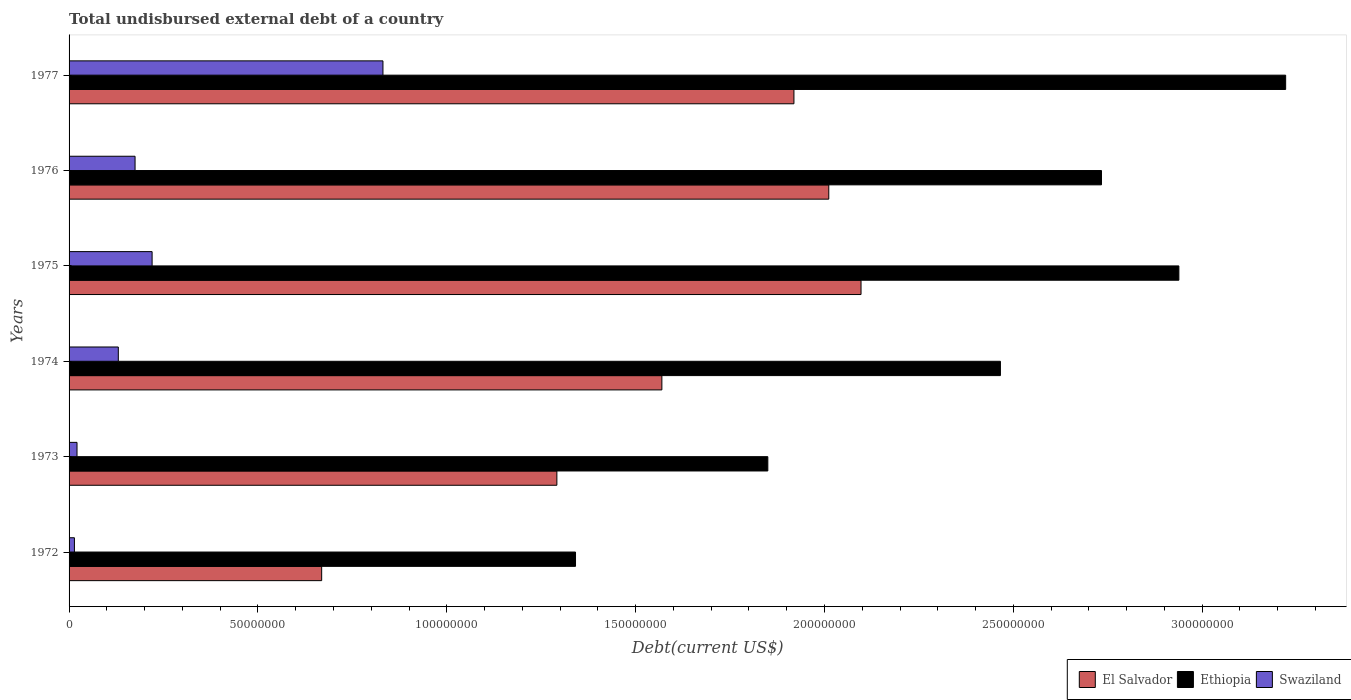Are the number of bars per tick equal to the number of legend labels?
Make the answer very short. Yes. How many bars are there on the 4th tick from the top?
Keep it short and to the point. 3. What is the total undisbursed external debt in Ethiopia in 1975?
Offer a terse response. 2.94e+08. Across all years, what is the maximum total undisbursed external debt in El Salvador?
Ensure brevity in your answer.  2.10e+08. Across all years, what is the minimum total undisbursed external debt in Swaziland?
Provide a succinct answer. 1.42e+06. In which year was the total undisbursed external debt in El Salvador maximum?
Your response must be concise. 1975. What is the total total undisbursed external debt in Ethiopia in the graph?
Make the answer very short. 1.45e+09. What is the difference between the total undisbursed external debt in Swaziland in 1973 and that in 1976?
Your response must be concise. -1.54e+07. What is the difference between the total undisbursed external debt in Ethiopia in 1977 and the total undisbursed external debt in El Salvador in 1973?
Offer a very short reply. 1.93e+08. What is the average total undisbursed external debt in Ethiopia per year?
Offer a terse response. 2.42e+08. In the year 1975, what is the difference between the total undisbursed external debt in Ethiopia and total undisbursed external debt in Swaziland?
Make the answer very short. 2.72e+08. In how many years, is the total undisbursed external debt in Ethiopia greater than 130000000 US$?
Give a very brief answer. 6. What is the ratio of the total undisbursed external debt in Ethiopia in 1972 to that in 1973?
Your answer should be very brief. 0.72. What is the difference between the highest and the second highest total undisbursed external debt in Ethiopia?
Ensure brevity in your answer.  2.83e+07. What is the difference between the highest and the lowest total undisbursed external debt in El Salvador?
Give a very brief answer. 1.43e+08. Is the sum of the total undisbursed external debt in Ethiopia in 1974 and 1975 greater than the maximum total undisbursed external debt in Swaziland across all years?
Your response must be concise. Yes. What does the 2nd bar from the top in 1974 represents?
Your answer should be compact. Ethiopia. What does the 3rd bar from the bottom in 1973 represents?
Your answer should be compact. Swaziland. Are all the bars in the graph horizontal?
Ensure brevity in your answer.  Yes. How many years are there in the graph?
Offer a terse response. 6. Where does the legend appear in the graph?
Make the answer very short. Bottom right. How many legend labels are there?
Offer a terse response. 3. What is the title of the graph?
Make the answer very short. Total undisbursed external debt of a country. Does "Guam" appear as one of the legend labels in the graph?
Ensure brevity in your answer.  No. What is the label or title of the X-axis?
Your answer should be compact. Debt(current US$). What is the Debt(current US$) of El Salvador in 1972?
Your answer should be very brief. 6.69e+07. What is the Debt(current US$) of Ethiopia in 1972?
Make the answer very short. 1.34e+08. What is the Debt(current US$) in Swaziland in 1972?
Your answer should be very brief. 1.42e+06. What is the Debt(current US$) in El Salvador in 1973?
Keep it short and to the point. 1.29e+08. What is the Debt(current US$) in Ethiopia in 1973?
Your answer should be compact. 1.85e+08. What is the Debt(current US$) in Swaziland in 1973?
Make the answer very short. 2.10e+06. What is the Debt(current US$) of El Salvador in 1974?
Give a very brief answer. 1.57e+08. What is the Debt(current US$) in Ethiopia in 1974?
Provide a succinct answer. 2.47e+08. What is the Debt(current US$) of Swaziland in 1974?
Your answer should be very brief. 1.30e+07. What is the Debt(current US$) in El Salvador in 1975?
Your answer should be very brief. 2.10e+08. What is the Debt(current US$) in Ethiopia in 1975?
Provide a succinct answer. 2.94e+08. What is the Debt(current US$) in Swaziland in 1975?
Your response must be concise. 2.20e+07. What is the Debt(current US$) of El Salvador in 1976?
Your answer should be very brief. 2.01e+08. What is the Debt(current US$) in Ethiopia in 1976?
Your answer should be very brief. 2.73e+08. What is the Debt(current US$) in Swaziland in 1976?
Your answer should be compact. 1.75e+07. What is the Debt(current US$) of El Salvador in 1977?
Provide a succinct answer. 1.92e+08. What is the Debt(current US$) of Ethiopia in 1977?
Your response must be concise. 3.22e+08. What is the Debt(current US$) of Swaziland in 1977?
Provide a succinct answer. 8.31e+07. Across all years, what is the maximum Debt(current US$) of El Salvador?
Your response must be concise. 2.10e+08. Across all years, what is the maximum Debt(current US$) in Ethiopia?
Provide a short and direct response. 3.22e+08. Across all years, what is the maximum Debt(current US$) in Swaziland?
Offer a terse response. 8.31e+07. Across all years, what is the minimum Debt(current US$) in El Salvador?
Your response must be concise. 6.69e+07. Across all years, what is the minimum Debt(current US$) of Ethiopia?
Your answer should be very brief. 1.34e+08. Across all years, what is the minimum Debt(current US$) of Swaziland?
Offer a very short reply. 1.42e+06. What is the total Debt(current US$) in El Salvador in the graph?
Provide a succinct answer. 9.56e+08. What is the total Debt(current US$) in Ethiopia in the graph?
Provide a succinct answer. 1.45e+09. What is the total Debt(current US$) of Swaziland in the graph?
Your answer should be compact. 1.39e+08. What is the difference between the Debt(current US$) of El Salvador in 1972 and that in 1973?
Offer a very short reply. -6.23e+07. What is the difference between the Debt(current US$) in Ethiopia in 1972 and that in 1973?
Your answer should be compact. -5.09e+07. What is the difference between the Debt(current US$) in Swaziland in 1972 and that in 1973?
Your answer should be very brief. -6.87e+05. What is the difference between the Debt(current US$) in El Salvador in 1972 and that in 1974?
Provide a succinct answer. -9.01e+07. What is the difference between the Debt(current US$) of Ethiopia in 1972 and that in 1974?
Offer a very short reply. -1.12e+08. What is the difference between the Debt(current US$) in Swaziland in 1972 and that in 1974?
Ensure brevity in your answer.  -1.16e+07. What is the difference between the Debt(current US$) in El Salvador in 1972 and that in 1975?
Your response must be concise. -1.43e+08. What is the difference between the Debt(current US$) in Ethiopia in 1972 and that in 1975?
Offer a very short reply. -1.60e+08. What is the difference between the Debt(current US$) of Swaziland in 1972 and that in 1975?
Your answer should be very brief. -2.06e+07. What is the difference between the Debt(current US$) of El Salvador in 1972 and that in 1976?
Your answer should be compact. -1.34e+08. What is the difference between the Debt(current US$) in Ethiopia in 1972 and that in 1976?
Keep it short and to the point. -1.39e+08. What is the difference between the Debt(current US$) in Swaziland in 1972 and that in 1976?
Your answer should be very brief. -1.61e+07. What is the difference between the Debt(current US$) of El Salvador in 1972 and that in 1977?
Your answer should be very brief. -1.25e+08. What is the difference between the Debt(current US$) of Ethiopia in 1972 and that in 1977?
Offer a very short reply. -1.88e+08. What is the difference between the Debt(current US$) in Swaziland in 1972 and that in 1977?
Make the answer very short. -8.17e+07. What is the difference between the Debt(current US$) of El Salvador in 1973 and that in 1974?
Make the answer very short. -2.78e+07. What is the difference between the Debt(current US$) of Ethiopia in 1973 and that in 1974?
Make the answer very short. -6.16e+07. What is the difference between the Debt(current US$) in Swaziland in 1973 and that in 1974?
Provide a succinct answer. -1.09e+07. What is the difference between the Debt(current US$) in El Salvador in 1973 and that in 1975?
Ensure brevity in your answer.  -8.05e+07. What is the difference between the Debt(current US$) of Ethiopia in 1973 and that in 1975?
Provide a short and direct response. -1.09e+08. What is the difference between the Debt(current US$) in Swaziland in 1973 and that in 1975?
Provide a succinct answer. -1.99e+07. What is the difference between the Debt(current US$) of El Salvador in 1973 and that in 1976?
Provide a short and direct response. -7.20e+07. What is the difference between the Debt(current US$) of Ethiopia in 1973 and that in 1976?
Make the answer very short. -8.83e+07. What is the difference between the Debt(current US$) in Swaziland in 1973 and that in 1976?
Keep it short and to the point. -1.54e+07. What is the difference between the Debt(current US$) of El Salvador in 1973 and that in 1977?
Offer a very short reply. -6.28e+07. What is the difference between the Debt(current US$) in Ethiopia in 1973 and that in 1977?
Your answer should be compact. -1.37e+08. What is the difference between the Debt(current US$) of Swaziland in 1973 and that in 1977?
Give a very brief answer. -8.10e+07. What is the difference between the Debt(current US$) of El Salvador in 1974 and that in 1975?
Ensure brevity in your answer.  -5.27e+07. What is the difference between the Debt(current US$) in Ethiopia in 1974 and that in 1975?
Provide a succinct answer. -4.72e+07. What is the difference between the Debt(current US$) in Swaziland in 1974 and that in 1975?
Offer a very short reply. -8.95e+06. What is the difference between the Debt(current US$) in El Salvador in 1974 and that in 1976?
Your answer should be very brief. -4.42e+07. What is the difference between the Debt(current US$) in Ethiopia in 1974 and that in 1976?
Keep it short and to the point. -2.68e+07. What is the difference between the Debt(current US$) of Swaziland in 1974 and that in 1976?
Your answer should be compact. -4.43e+06. What is the difference between the Debt(current US$) in El Salvador in 1974 and that in 1977?
Provide a succinct answer. -3.50e+07. What is the difference between the Debt(current US$) in Ethiopia in 1974 and that in 1977?
Keep it short and to the point. -7.55e+07. What is the difference between the Debt(current US$) in Swaziland in 1974 and that in 1977?
Ensure brevity in your answer.  -7.01e+07. What is the difference between the Debt(current US$) of El Salvador in 1975 and that in 1976?
Offer a very short reply. 8.54e+06. What is the difference between the Debt(current US$) in Ethiopia in 1975 and that in 1976?
Offer a very short reply. 2.05e+07. What is the difference between the Debt(current US$) in Swaziland in 1975 and that in 1976?
Provide a short and direct response. 4.52e+06. What is the difference between the Debt(current US$) in El Salvador in 1975 and that in 1977?
Make the answer very short. 1.78e+07. What is the difference between the Debt(current US$) in Ethiopia in 1975 and that in 1977?
Your response must be concise. -2.83e+07. What is the difference between the Debt(current US$) in Swaziland in 1975 and that in 1977?
Your response must be concise. -6.11e+07. What is the difference between the Debt(current US$) of El Salvador in 1976 and that in 1977?
Offer a very short reply. 9.23e+06. What is the difference between the Debt(current US$) in Ethiopia in 1976 and that in 1977?
Offer a very short reply. -4.88e+07. What is the difference between the Debt(current US$) of Swaziland in 1976 and that in 1977?
Keep it short and to the point. -6.56e+07. What is the difference between the Debt(current US$) of El Salvador in 1972 and the Debt(current US$) of Ethiopia in 1973?
Give a very brief answer. -1.18e+08. What is the difference between the Debt(current US$) in El Salvador in 1972 and the Debt(current US$) in Swaziland in 1973?
Ensure brevity in your answer.  6.48e+07. What is the difference between the Debt(current US$) in Ethiopia in 1972 and the Debt(current US$) in Swaziland in 1973?
Offer a very short reply. 1.32e+08. What is the difference between the Debt(current US$) of El Salvador in 1972 and the Debt(current US$) of Ethiopia in 1974?
Keep it short and to the point. -1.80e+08. What is the difference between the Debt(current US$) in El Salvador in 1972 and the Debt(current US$) in Swaziland in 1974?
Your answer should be very brief. 5.38e+07. What is the difference between the Debt(current US$) of Ethiopia in 1972 and the Debt(current US$) of Swaziland in 1974?
Ensure brevity in your answer.  1.21e+08. What is the difference between the Debt(current US$) in El Salvador in 1972 and the Debt(current US$) in Ethiopia in 1975?
Ensure brevity in your answer.  -2.27e+08. What is the difference between the Debt(current US$) of El Salvador in 1972 and the Debt(current US$) of Swaziland in 1975?
Offer a terse response. 4.49e+07. What is the difference between the Debt(current US$) in Ethiopia in 1972 and the Debt(current US$) in Swaziland in 1975?
Give a very brief answer. 1.12e+08. What is the difference between the Debt(current US$) in El Salvador in 1972 and the Debt(current US$) in Ethiopia in 1976?
Your answer should be very brief. -2.06e+08. What is the difference between the Debt(current US$) of El Salvador in 1972 and the Debt(current US$) of Swaziland in 1976?
Provide a succinct answer. 4.94e+07. What is the difference between the Debt(current US$) of Ethiopia in 1972 and the Debt(current US$) of Swaziland in 1976?
Ensure brevity in your answer.  1.17e+08. What is the difference between the Debt(current US$) in El Salvador in 1972 and the Debt(current US$) in Ethiopia in 1977?
Ensure brevity in your answer.  -2.55e+08. What is the difference between the Debt(current US$) of El Salvador in 1972 and the Debt(current US$) of Swaziland in 1977?
Provide a succinct answer. -1.62e+07. What is the difference between the Debt(current US$) of Ethiopia in 1972 and the Debt(current US$) of Swaziland in 1977?
Offer a terse response. 5.10e+07. What is the difference between the Debt(current US$) in El Salvador in 1973 and the Debt(current US$) in Ethiopia in 1974?
Your answer should be compact. -1.17e+08. What is the difference between the Debt(current US$) in El Salvador in 1973 and the Debt(current US$) in Swaziland in 1974?
Your response must be concise. 1.16e+08. What is the difference between the Debt(current US$) in Ethiopia in 1973 and the Debt(current US$) in Swaziland in 1974?
Your response must be concise. 1.72e+08. What is the difference between the Debt(current US$) of El Salvador in 1973 and the Debt(current US$) of Ethiopia in 1975?
Provide a succinct answer. -1.65e+08. What is the difference between the Debt(current US$) of El Salvador in 1973 and the Debt(current US$) of Swaziland in 1975?
Provide a short and direct response. 1.07e+08. What is the difference between the Debt(current US$) of Ethiopia in 1973 and the Debt(current US$) of Swaziland in 1975?
Provide a succinct answer. 1.63e+08. What is the difference between the Debt(current US$) in El Salvador in 1973 and the Debt(current US$) in Ethiopia in 1976?
Provide a short and direct response. -1.44e+08. What is the difference between the Debt(current US$) in El Salvador in 1973 and the Debt(current US$) in Swaziland in 1976?
Provide a short and direct response. 1.12e+08. What is the difference between the Debt(current US$) of Ethiopia in 1973 and the Debt(current US$) of Swaziland in 1976?
Give a very brief answer. 1.68e+08. What is the difference between the Debt(current US$) in El Salvador in 1973 and the Debt(current US$) in Ethiopia in 1977?
Offer a very short reply. -1.93e+08. What is the difference between the Debt(current US$) in El Salvador in 1973 and the Debt(current US$) in Swaziland in 1977?
Your response must be concise. 4.60e+07. What is the difference between the Debt(current US$) of Ethiopia in 1973 and the Debt(current US$) of Swaziland in 1977?
Keep it short and to the point. 1.02e+08. What is the difference between the Debt(current US$) of El Salvador in 1974 and the Debt(current US$) of Ethiopia in 1975?
Provide a succinct answer. -1.37e+08. What is the difference between the Debt(current US$) of El Salvador in 1974 and the Debt(current US$) of Swaziland in 1975?
Your answer should be very brief. 1.35e+08. What is the difference between the Debt(current US$) of Ethiopia in 1974 and the Debt(current US$) of Swaziland in 1975?
Ensure brevity in your answer.  2.25e+08. What is the difference between the Debt(current US$) of El Salvador in 1974 and the Debt(current US$) of Ethiopia in 1976?
Your answer should be compact. -1.16e+08. What is the difference between the Debt(current US$) of El Salvador in 1974 and the Debt(current US$) of Swaziland in 1976?
Give a very brief answer. 1.39e+08. What is the difference between the Debt(current US$) in Ethiopia in 1974 and the Debt(current US$) in Swaziland in 1976?
Provide a succinct answer. 2.29e+08. What is the difference between the Debt(current US$) of El Salvador in 1974 and the Debt(current US$) of Ethiopia in 1977?
Make the answer very short. -1.65e+08. What is the difference between the Debt(current US$) of El Salvador in 1974 and the Debt(current US$) of Swaziland in 1977?
Offer a very short reply. 7.38e+07. What is the difference between the Debt(current US$) in Ethiopia in 1974 and the Debt(current US$) in Swaziland in 1977?
Your answer should be compact. 1.63e+08. What is the difference between the Debt(current US$) of El Salvador in 1975 and the Debt(current US$) of Ethiopia in 1976?
Give a very brief answer. -6.37e+07. What is the difference between the Debt(current US$) of El Salvador in 1975 and the Debt(current US$) of Swaziland in 1976?
Offer a terse response. 1.92e+08. What is the difference between the Debt(current US$) of Ethiopia in 1975 and the Debt(current US$) of Swaziland in 1976?
Offer a very short reply. 2.76e+08. What is the difference between the Debt(current US$) of El Salvador in 1975 and the Debt(current US$) of Ethiopia in 1977?
Provide a short and direct response. -1.12e+08. What is the difference between the Debt(current US$) of El Salvador in 1975 and the Debt(current US$) of Swaziland in 1977?
Your answer should be compact. 1.27e+08. What is the difference between the Debt(current US$) of Ethiopia in 1975 and the Debt(current US$) of Swaziland in 1977?
Offer a terse response. 2.11e+08. What is the difference between the Debt(current US$) in El Salvador in 1976 and the Debt(current US$) in Ethiopia in 1977?
Keep it short and to the point. -1.21e+08. What is the difference between the Debt(current US$) of El Salvador in 1976 and the Debt(current US$) of Swaziland in 1977?
Your response must be concise. 1.18e+08. What is the difference between the Debt(current US$) of Ethiopia in 1976 and the Debt(current US$) of Swaziland in 1977?
Your answer should be very brief. 1.90e+08. What is the average Debt(current US$) in El Salvador per year?
Offer a very short reply. 1.59e+08. What is the average Debt(current US$) in Ethiopia per year?
Ensure brevity in your answer.  2.42e+08. What is the average Debt(current US$) in Swaziland per year?
Your answer should be compact. 2.32e+07. In the year 1972, what is the difference between the Debt(current US$) in El Salvador and Debt(current US$) in Ethiopia?
Give a very brief answer. -6.72e+07. In the year 1972, what is the difference between the Debt(current US$) of El Salvador and Debt(current US$) of Swaziland?
Provide a short and direct response. 6.55e+07. In the year 1972, what is the difference between the Debt(current US$) in Ethiopia and Debt(current US$) in Swaziland?
Your response must be concise. 1.33e+08. In the year 1973, what is the difference between the Debt(current US$) in El Salvador and Debt(current US$) in Ethiopia?
Offer a very short reply. -5.58e+07. In the year 1973, what is the difference between the Debt(current US$) in El Salvador and Debt(current US$) in Swaziland?
Give a very brief answer. 1.27e+08. In the year 1973, what is the difference between the Debt(current US$) in Ethiopia and Debt(current US$) in Swaziland?
Make the answer very short. 1.83e+08. In the year 1974, what is the difference between the Debt(current US$) in El Salvador and Debt(current US$) in Ethiopia?
Offer a very short reply. -8.96e+07. In the year 1974, what is the difference between the Debt(current US$) of El Salvador and Debt(current US$) of Swaziland?
Your answer should be compact. 1.44e+08. In the year 1974, what is the difference between the Debt(current US$) of Ethiopia and Debt(current US$) of Swaziland?
Provide a succinct answer. 2.34e+08. In the year 1975, what is the difference between the Debt(current US$) of El Salvador and Debt(current US$) of Ethiopia?
Make the answer very short. -8.42e+07. In the year 1975, what is the difference between the Debt(current US$) in El Salvador and Debt(current US$) in Swaziland?
Make the answer very short. 1.88e+08. In the year 1975, what is the difference between the Debt(current US$) in Ethiopia and Debt(current US$) in Swaziland?
Ensure brevity in your answer.  2.72e+08. In the year 1976, what is the difference between the Debt(current US$) of El Salvador and Debt(current US$) of Ethiopia?
Make the answer very short. -7.22e+07. In the year 1976, what is the difference between the Debt(current US$) in El Salvador and Debt(current US$) in Swaziland?
Offer a very short reply. 1.84e+08. In the year 1976, what is the difference between the Debt(current US$) in Ethiopia and Debt(current US$) in Swaziland?
Keep it short and to the point. 2.56e+08. In the year 1977, what is the difference between the Debt(current US$) of El Salvador and Debt(current US$) of Ethiopia?
Give a very brief answer. -1.30e+08. In the year 1977, what is the difference between the Debt(current US$) of El Salvador and Debt(current US$) of Swaziland?
Keep it short and to the point. 1.09e+08. In the year 1977, what is the difference between the Debt(current US$) in Ethiopia and Debt(current US$) in Swaziland?
Provide a short and direct response. 2.39e+08. What is the ratio of the Debt(current US$) in El Salvador in 1972 to that in 1973?
Ensure brevity in your answer.  0.52. What is the ratio of the Debt(current US$) in Ethiopia in 1972 to that in 1973?
Offer a very short reply. 0.72. What is the ratio of the Debt(current US$) of Swaziland in 1972 to that in 1973?
Make the answer very short. 0.67. What is the ratio of the Debt(current US$) in El Salvador in 1972 to that in 1974?
Ensure brevity in your answer.  0.43. What is the ratio of the Debt(current US$) of Ethiopia in 1972 to that in 1974?
Make the answer very short. 0.54. What is the ratio of the Debt(current US$) of Swaziland in 1972 to that in 1974?
Make the answer very short. 0.11. What is the ratio of the Debt(current US$) of El Salvador in 1972 to that in 1975?
Keep it short and to the point. 0.32. What is the ratio of the Debt(current US$) in Ethiopia in 1972 to that in 1975?
Your response must be concise. 0.46. What is the ratio of the Debt(current US$) in Swaziland in 1972 to that in 1975?
Offer a very short reply. 0.06. What is the ratio of the Debt(current US$) of El Salvador in 1972 to that in 1976?
Your answer should be very brief. 0.33. What is the ratio of the Debt(current US$) in Ethiopia in 1972 to that in 1976?
Your response must be concise. 0.49. What is the ratio of the Debt(current US$) in Swaziland in 1972 to that in 1976?
Ensure brevity in your answer.  0.08. What is the ratio of the Debt(current US$) in El Salvador in 1972 to that in 1977?
Keep it short and to the point. 0.35. What is the ratio of the Debt(current US$) in Ethiopia in 1972 to that in 1977?
Keep it short and to the point. 0.42. What is the ratio of the Debt(current US$) of Swaziland in 1972 to that in 1977?
Offer a very short reply. 0.02. What is the ratio of the Debt(current US$) in El Salvador in 1973 to that in 1974?
Your answer should be very brief. 0.82. What is the ratio of the Debt(current US$) of Ethiopia in 1973 to that in 1974?
Your answer should be very brief. 0.75. What is the ratio of the Debt(current US$) in Swaziland in 1973 to that in 1974?
Offer a very short reply. 0.16. What is the ratio of the Debt(current US$) of El Salvador in 1973 to that in 1975?
Your answer should be compact. 0.62. What is the ratio of the Debt(current US$) of Ethiopia in 1973 to that in 1975?
Offer a very short reply. 0.63. What is the ratio of the Debt(current US$) in Swaziland in 1973 to that in 1975?
Provide a succinct answer. 0.1. What is the ratio of the Debt(current US$) in El Salvador in 1973 to that in 1976?
Give a very brief answer. 0.64. What is the ratio of the Debt(current US$) in Ethiopia in 1973 to that in 1976?
Provide a succinct answer. 0.68. What is the ratio of the Debt(current US$) of Swaziland in 1973 to that in 1976?
Offer a terse response. 0.12. What is the ratio of the Debt(current US$) of El Salvador in 1973 to that in 1977?
Your response must be concise. 0.67. What is the ratio of the Debt(current US$) of Ethiopia in 1973 to that in 1977?
Provide a succinct answer. 0.57. What is the ratio of the Debt(current US$) in Swaziland in 1973 to that in 1977?
Provide a short and direct response. 0.03. What is the ratio of the Debt(current US$) of El Salvador in 1974 to that in 1975?
Your answer should be compact. 0.75. What is the ratio of the Debt(current US$) in Ethiopia in 1974 to that in 1975?
Keep it short and to the point. 0.84. What is the ratio of the Debt(current US$) in Swaziland in 1974 to that in 1975?
Offer a terse response. 0.59. What is the ratio of the Debt(current US$) of El Salvador in 1974 to that in 1976?
Offer a terse response. 0.78. What is the ratio of the Debt(current US$) of Ethiopia in 1974 to that in 1976?
Give a very brief answer. 0.9. What is the ratio of the Debt(current US$) in Swaziland in 1974 to that in 1976?
Your response must be concise. 0.75. What is the ratio of the Debt(current US$) in El Salvador in 1974 to that in 1977?
Your answer should be compact. 0.82. What is the ratio of the Debt(current US$) in Ethiopia in 1974 to that in 1977?
Ensure brevity in your answer.  0.77. What is the ratio of the Debt(current US$) in Swaziland in 1974 to that in 1977?
Give a very brief answer. 0.16. What is the ratio of the Debt(current US$) in El Salvador in 1975 to that in 1976?
Provide a short and direct response. 1.04. What is the ratio of the Debt(current US$) in Ethiopia in 1975 to that in 1976?
Keep it short and to the point. 1.07. What is the ratio of the Debt(current US$) of Swaziland in 1975 to that in 1976?
Make the answer very short. 1.26. What is the ratio of the Debt(current US$) of El Salvador in 1975 to that in 1977?
Your answer should be compact. 1.09. What is the ratio of the Debt(current US$) of Ethiopia in 1975 to that in 1977?
Your answer should be very brief. 0.91. What is the ratio of the Debt(current US$) of Swaziland in 1975 to that in 1977?
Provide a short and direct response. 0.26. What is the ratio of the Debt(current US$) in El Salvador in 1976 to that in 1977?
Keep it short and to the point. 1.05. What is the ratio of the Debt(current US$) of Ethiopia in 1976 to that in 1977?
Provide a succinct answer. 0.85. What is the ratio of the Debt(current US$) in Swaziland in 1976 to that in 1977?
Offer a very short reply. 0.21. What is the difference between the highest and the second highest Debt(current US$) of El Salvador?
Offer a terse response. 8.54e+06. What is the difference between the highest and the second highest Debt(current US$) in Ethiopia?
Give a very brief answer. 2.83e+07. What is the difference between the highest and the second highest Debt(current US$) in Swaziland?
Make the answer very short. 6.11e+07. What is the difference between the highest and the lowest Debt(current US$) in El Salvador?
Offer a terse response. 1.43e+08. What is the difference between the highest and the lowest Debt(current US$) in Ethiopia?
Your answer should be very brief. 1.88e+08. What is the difference between the highest and the lowest Debt(current US$) of Swaziland?
Make the answer very short. 8.17e+07. 